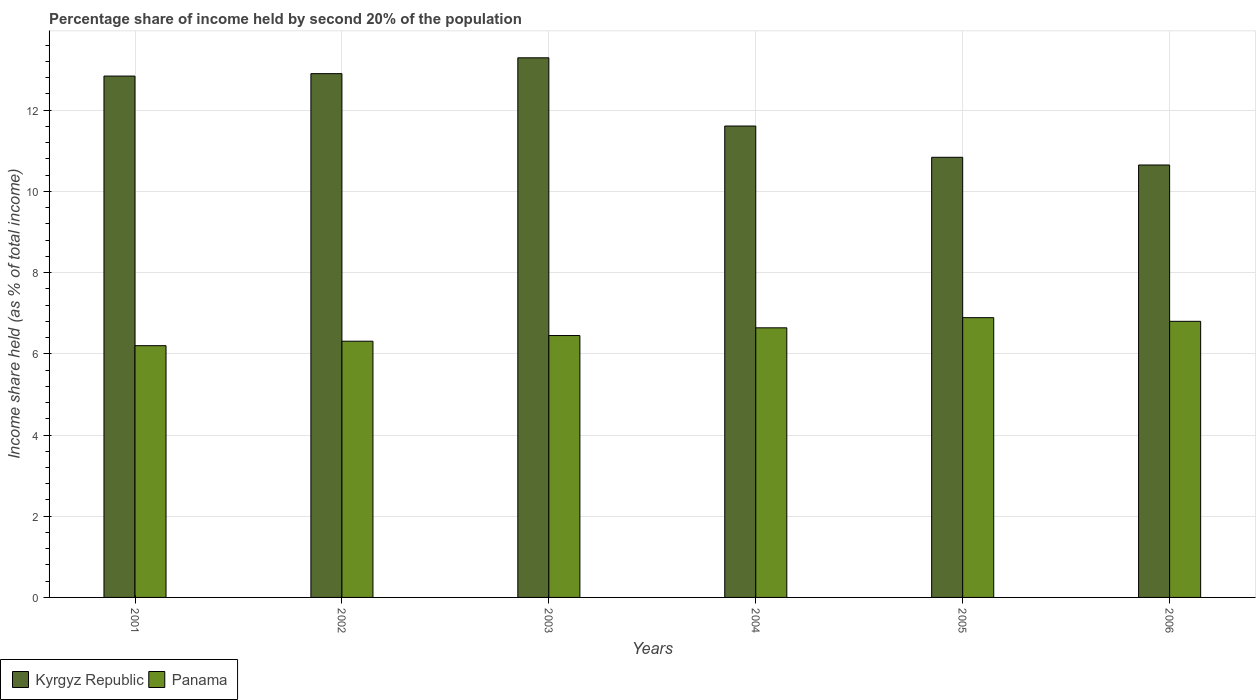Are the number of bars per tick equal to the number of legend labels?
Make the answer very short. Yes. Are the number of bars on each tick of the X-axis equal?
Your answer should be compact. Yes. In how many cases, is the number of bars for a given year not equal to the number of legend labels?
Provide a short and direct response. 0. What is the share of income held by second 20% of the population in Panama in 2001?
Make the answer very short. 6.2. Across all years, what is the maximum share of income held by second 20% of the population in Kyrgyz Republic?
Ensure brevity in your answer.  13.29. Across all years, what is the minimum share of income held by second 20% of the population in Panama?
Provide a succinct answer. 6.2. In which year was the share of income held by second 20% of the population in Panama maximum?
Your response must be concise. 2005. What is the total share of income held by second 20% of the population in Panama in the graph?
Your answer should be compact. 39.29. What is the difference between the share of income held by second 20% of the population in Panama in 2005 and the share of income held by second 20% of the population in Kyrgyz Republic in 2002?
Offer a terse response. -6.01. What is the average share of income held by second 20% of the population in Kyrgyz Republic per year?
Offer a terse response. 12.02. In the year 2004, what is the difference between the share of income held by second 20% of the population in Panama and share of income held by second 20% of the population in Kyrgyz Republic?
Ensure brevity in your answer.  -4.97. In how many years, is the share of income held by second 20% of the population in Kyrgyz Republic greater than 11.2 %?
Provide a succinct answer. 4. What is the ratio of the share of income held by second 20% of the population in Kyrgyz Republic in 2002 to that in 2003?
Offer a very short reply. 0.97. Is the difference between the share of income held by second 20% of the population in Panama in 2004 and 2005 greater than the difference between the share of income held by second 20% of the population in Kyrgyz Republic in 2004 and 2005?
Provide a succinct answer. No. What is the difference between the highest and the second highest share of income held by second 20% of the population in Kyrgyz Republic?
Provide a succinct answer. 0.39. What is the difference between the highest and the lowest share of income held by second 20% of the population in Panama?
Give a very brief answer. 0.69. What does the 2nd bar from the left in 2004 represents?
Give a very brief answer. Panama. What does the 2nd bar from the right in 2005 represents?
Your answer should be compact. Kyrgyz Republic. Does the graph contain grids?
Provide a succinct answer. Yes. How many legend labels are there?
Provide a short and direct response. 2. What is the title of the graph?
Your response must be concise. Percentage share of income held by second 20% of the population. Does "High income" appear as one of the legend labels in the graph?
Ensure brevity in your answer.  No. What is the label or title of the X-axis?
Ensure brevity in your answer.  Years. What is the label or title of the Y-axis?
Provide a succinct answer. Income share held (as % of total income). What is the Income share held (as % of total income) in Kyrgyz Republic in 2001?
Your answer should be compact. 12.84. What is the Income share held (as % of total income) of Kyrgyz Republic in 2002?
Provide a short and direct response. 12.9. What is the Income share held (as % of total income) in Panama in 2002?
Your answer should be very brief. 6.31. What is the Income share held (as % of total income) of Kyrgyz Republic in 2003?
Ensure brevity in your answer.  13.29. What is the Income share held (as % of total income) of Panama in 2003?
Offer a very short reply. 6.45. What is the Income share held (as % of total income) of Kyrgyz Republic in 2004?
Your response must be concise. 11.61. What is the Income share held (as % of total income) in Panama in 2004?
Provide a short and direct response. 6.64. What is the Income share held (as % of total income) of Kyrgyz Republic in 2005?
Give a very brief answer. 10.84. What is the Income share held (as % of total income) of Panama in 2005?
Offer a terse response. 6.89. What is the Income share held (as % of total income) in Kyrgyz Republic in 2006?
Keep it short and to the point. 10.65. What is the Income share held (as % of total income) of Panama in 2006?
Offer a very short reply. 6.8. Across all years, what is the maximum Income share held (as % of total income) of Kyrgyz Republic?
Keep it short and to the point. 13.29. Across all years, what is the maximum Income share held (as % of total income) of Panama?
Keep it short and to the point. 6.89. Across all years, what is the minimum Income share held (as % of total income) in Kyrgyz Republic?
Give a very brief answer. 10.65. Across all years, what is the minimum Income share held (as % of total income) in Panama?
Provide a short and direct response. 6.2. What is the total Income share held (as % of total income) of Kyrgyz Republic in the graph?
Offer a very short reply. 72.13. What is the total Income share held (as % of total income) of Panama in the graph?
Offer a terse response. 39.29. What is the difference between the Income share held (as % of total income) in Kyrgyz Republic in 2001 and that in 2002?
Provide a succinct answer. -0.06. What is the difference between the Income share held (as % of total income) in Panama in 2001 and that in 2002?
Make the answer very short. -0.11. What is the difference between the Income share held (as % of total income) of Kyrgyz Republic in 2001 and that in 2003?
Give a very brief answer. -0.45. What is the difference between the Income share held (as % of total income) of Kyrgyz Republic in 2001 and that in 2004?
Provide a short and direct response. 1.23. What is the difference between the Income share held (as % of total income) of Panama in 2001 and that in 2004?
Your answer should be very brief. -0.44. What is the difference between the Income share held (as % of total income) of Panama in 2001 and that in 2005?
Offer a terse response. -0.69. What is the difference between the Income share held (as % of total income) in Kyrgyz Republic in 2001 and that in 2006?
Offer a terse response. 2.19. What is the difference between the Income share held (as % of total income) of Kyrgyz Republic in 2002 and that in 2003?
Your answer should be very brief. -0.39. What is the difference between the Income share held (as % of total income) in Panama in 2002 and that in 2003?
Your response must be concise. -0.14. What is the difference between the Income share held (as % of total income) in Kyrgyz Republic in 2002 and that in 2004?
Offer a very short reply. 1.29. What is the difference between the Income share held (as % of total income) of Panama in 2002 and that in 2004?
Provide a succinct answer. -0.33. What is the difference between the Income share held (as % of total income) of Kyrgyz Republic in 2002 and that in 2005?
Provide a succinct answer. 2.06. What is the difference between the Income share held (as % of total income) of Panama in 2002 and that in 2005?
Provide a succinct answer. -0.58. What is the difference between the Income share held (as % of total income) of Kyrgyz Republic in 2002 and that in 2006?
Offer a terse response. 2.25. What is the difference between the Income share held (as % of total income) of Panama in 2002 and that in 2006?
Keep it short and to the point. -0.49. What is the difference between the Income share held (as % of total income) of Kyrgyz Republic in 2003 and that in 2004?
Provide a succinct answer. 1.68. What is the difference between the Income share held (as % of total income) of Panama in 2003 and that in 2004?
Offer a terse response. -0.19. What is the difference between the Income share held (as % of total income) of Kyrgyz Republic in 2003 and that in 2005?
Ensure brevity in your answer.  2.45. What is the difference between the Income share held (as % of total income) of Panama in 2003 and that in 2005?
Keep it short and to the point. -0.44. What is the difference between the Income share held (as % of total income) of Kyrgyz Republic in 2003 and that in 2006?
Give a very brief answer. 2.64. What is the difference between the Income share held (as % of total income) of Panama in 2003 and that in 2006?
Ensure brevity in your answer.  -0.35. What is the difference between the Income share held (as % of total income) in Kyrgyz Republic in 2004 and that in 2005?
Give a very brief answer. 0.77. What is the difference between the Income share held (as % of total income) in Panama in 2004 and that in 2005?
Offer a very short reply. -0.25. What is the difference between the Income share held (as % of total income) of Panama in 2004 and that in 2006?
Your answer should be very brief. -0.16. What is the difference between the Income share held (as % of total income) in Kyrgyz Republic in 2005 and that in 2006?
Offer a terse response. 0.19. What is the difference between the Income share held (as % of total income) in Panama in 2005 and that in 2006?
Provide a short and direct response. 0.09. What is the difference between the Income share held (as % of total income) in Kyrgyz Republic in 2001 and the Income share held (as % of total income) in Panama in 2002?
Give a very brief answer. 6.53. What is the difference between the Income share held (as % of total income) in Kyrgyz Republic in 2001 and the Income share held (as % of total income) in Panama in 2003?
Make the answer very short. 6.39. What is the difference between the Income share held (as % of total income) in Kyrgyz Republic in 2001 and the Income share held (as % of total income) in Panama in 2004?
Your response must be concise. 6.2. What is the difference between the Income share held (as % of total income) of Kyrgyz Republic in 2001 and the Income share held (as % of total income) of Panama in 2005?
Keep it short and to the point. 5.95. What is the difference between the Income share held (as % of total income) of Kyrgyz Republic in 2001 and the Income share held (as % of total income) of Panama in 2006?
Provide a succinct answer. 6.04. What is the difference between the Income share held (as % of total income) of Kyrgyz Republic in 2002 and the Income share held (as % of total income) of Panama in 2003?
Make the answer very short. 6.45. What is the difference between the Income share held (as % of total income) of Kyrgyz Republic in 2002 and the Income share held (as % of total income) of Panama in 2004?
Provide a short and direct response. 6.26. What is the difference between the Income share held (as % of total income) of Kyrgyz Republic in 2002 and the Income share held (as % of total income) of Panama in 2005?
Your answer should be very brief. 6.01. What is the difference between the Income share held (as % of total income) in Kyrgyz Republic in 2003 and the Income share held (as % of total income) in Panama in 2004?
Provide a short and direct response. 6.65. What is the difference between the Income share held (as % of total income) of Kyrgyz Republic in 2003 and the Income share held (as % of total income) of Panama in 2006?
Your answer should be very brief. 6.49. What is the difference between the Income share held (as % of total income) of Kyrgyz Republic in 2004 and the Income share held (as % of total income) of Panama in 2005?
Provide a short and direct response. 4.72. What is the difference between the Income share held (as % of total income) of Kyrgyz Republic in 2004 and the Income share held (as % of total income) of Panama in 2006?
Offer a very short reply. 4.81. What is the difference between the Income share held (as % of total income) of Kyrgyz Republic in 2005 and the Income share held (as % of total income) of Panama in 2006?
Your response must be concise. 4.04. What is the average Income share held (as % of total income) of Kyrgyz Republic per year?
Ensure brevity in your answer.  12.02. What is the average Income share held (as % of total income) in Panama per year?
Keep it short and to the point. 6.55. In the year 2001, what is the difference between the Income share held (as % of total income) in Kyrgyz Republic and Income share held (as % of total income) in Panama?
Keep it short and to the point. 6.64. In the year 2002, what is the difference between the Income share held (as % of total income) of Kyrgyz Republic and Income share held (as % of total income) of Panama?
Give a very brief answer. 6.59. In the year 2003, what is the difference between the Income share held (as % of total income) of Kyrgyz Republic and Income share held (as % of total income) of Panama?
Ensure brevity in your answer.  6.84. In the year 2004, what is the difference between the Income share held (as % of total income) of Kyrgyz Republic and Income share held (as % of total income) of Panama?
Ensure brevity in your answer.  4.97. In the year 2005, what is the difference between the Income share held (as % of total income) in Kyrgyz Republic and Income share held (as % of total income) in Panama?
Give a very brief answer. 3.95. In the year 2006, what is the difference between the Income share held (as % of total income) of Kyrgyz Republic and Income share held (as % of total income) of Panama?
Keep it short and to the point. 3.85. What is the ratio of the Income share held (as % of total income) in Kyrgyz Republic in 2001 to that in 2002?
Provide a succinct answer. 1. What is the ratio of the Income share held (as % of total income) of Panama in 2001 to that in 2002?
Your response must be concise. 0.98. What is the ratio of the Income share held (as % of total income) in Kyrgyz Republic in 2001 to that in 2003?
Offer a very short reply. 0.97. What is the ratio of the Income share held (as % of total income) in Panama in 2001 to that in 2003?
Your response must be concise. 0.96. What is the ratio of the Income share held (as % of total income) in Kyrgyz Republic in 2001 to that in 2004?
Your answer should be very brief. 1.11. What is the ratio of the Income share held (as % of total income) in Panama in 2001 to that in 2004?
Make the answer very short. 0.93. What is the ratio of the Income share held (as % of total income) of Kyrgyz Republic in 2001 to that in 2005?
Provide a short and direct response. 1.18. What is the ratio of the Income share held (as % of total income) of Panama in 2001 to that in 2005?
Offer a terse response. 0.9. What is the ratio of the Income share held (as % of total income) in Kyrgyz Republic in 2001 to that in 2006?
Your response must be concise. 1.21. What is the ratio of the Income share held (as % of total income) in Panama in 2001 to that in 2006?
Give a very brief answer. 0.91. What is the ratio of the Income share held (as % of total income) of Kyrgyz Republic in 2002 to that in 2003?
Make the answer very short. 0.97. What is the ratio of the Income share held (as % of total income) of Panama in 2002 to that in 2003?
Make the answer very short. 0.98. What is the ratio of the Income share held (as % of total income) of Panama in 2002 to that in 2004?
Your answer should be very brief. 0.95. What is the ratio of the Income share held (as % of total income) of Kyrgyz Republic in 2002 to that in 2005?
Your response must be concise. 1.19. What is the ratio of the Income share held (as % of total income) in Panama in 2002 to that in 2005?
Provide a succinct answer. 0.92. What is the ratio of the Income share held (as % of total income) in Kyrgyz Republic in 2002 to that in 2006?
Offer a very short reply. 1.21. What is the ratio of the Income share held (as % of total income) in Panama in 2002 to that in 2006?
Keep it short and to the point. 0.93. What is the ratio of the Income share held (as % of total income) of Kyrgyz Republic in 2003 to that in 2004?
Your response must be concise. 1.14. What is the ratio of the Income share held (as % of total income) in Panama in 2003 to that in 2004?
Your answer should be very brief. 0.97. What is the ratio of the Income share held (as % of total income) of Kyrgyz Republic in 2003 to that in 2005?
Ensure brevity in your answer.  1.23. What is the ratio of the Income share held (as % of total income) of Panama in 2003 to that in 2005?
Ensure brevity in your answer.  0.94. What is the ratio of the Income share held (as % of total income) in Kyrgyz Republic in 2003 to that in 2006?
Provide a short and direct response. 1.25. What is the ratio of the Income share held (as % of total income) of Panama in 2003 to that in 2006?
Make the answer very short. 0.95. What is the ratio of the Income share held (as % of total income) in Kyrgyz Republic in 2004 to that in 2005?
Provide a succinct answer. 1.07. What is the ratio of the Income share held (as % of total income) of Panama in 2004 to that in 2005?
Offer a terse response. 0.96. What is the ratio of the Income share held (as % of total income) of Kyrgyz Republic in 2004 to that in 2006?
Offer a very short reply. 1.09. What is the ratio of the Income share held (as % of total income) in Panama in 2004 to that in 2006?
Your answer should be compact. 0.98. What is the ratio of the Income share held (as % of total income) of Kyrgyz Republic in 2005 to that in 2006?
Make the answer very short. 1.02. What is the ratio of the Income share held (as % of total income) of Panama in 2005 to that in 2006?
Provide a succinct answer. 1.01. What is the difference between the highest and the second highest Income share held (as % of total income) in Kyrgyz Republic?
Make the answer very short. 0.39. What is the difference between the highest and the second highest Income share held (as % of total income) of Panama?
Your answer should be very brief. 0.09. What is the difference between the highest and the lowest Income share held (as % of total income) of Kyrgyz Republic?
Your answer should be very brief. 2.64. What is the difference between the highest and the lowest Income share held (as % of total income) in Panama?
Ensure brevity in your answer.  0.69. 